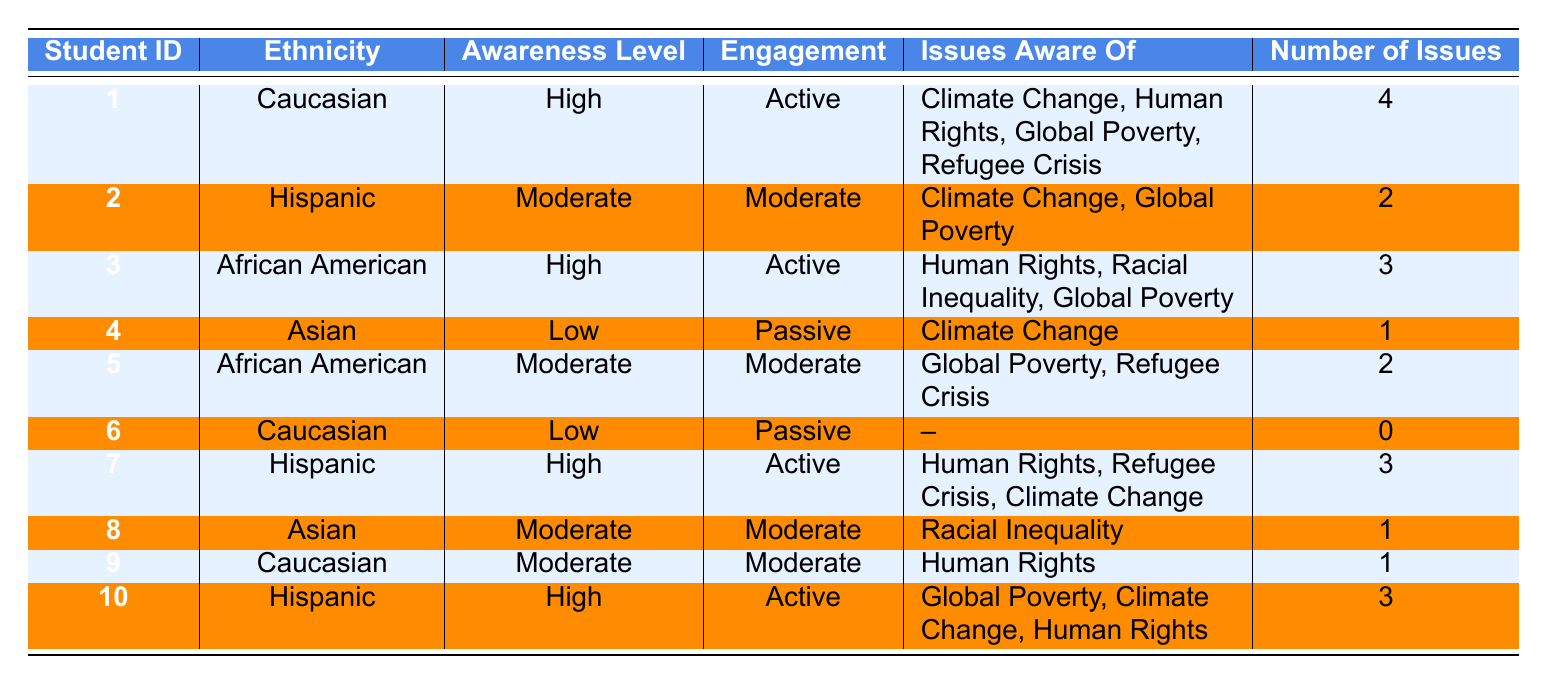What is the ethnic background of the student with the highest awareness level? The student with the highest awareness level is Student 1, who is Caucasian. There are two other students (Student 3 and Student 10) who also have a high awareness level, but since the question asks for the one with the highest level, Student 1 is the first listed.
Answer: Caucasian How many students have a low level of awareness? There are two students (Student 4 and Student 6) who have a low awareness level according to the table.
Answer: 2 Which ethnic group has the most students listed in the table? By counting the number of entries for each ethnicity, Caucasian has three students (1, 6, 9), Hispanic has three students (2, 7, 10), African American has two students (3, 5), and Asian has two students (4, 8). There is a tie between Caucasian and Hispanic for the most students, with three each.
Answer: Caucasian and Hispanic What percentage of Hispanic students have a high awareness level? There are three Hispanic students in total (2, 7, 10). Out of these, two (7 and 10) have a high awareness level. To calculate the percentage: (2 high awareness students / 3 total Hispanic students) * 100 = 66.67%.
Answer: 66.67% Is it true that all Asian students have a moderate awareness level? There are two Asian students (4 and 8). Student 4 has a low awareness level, while Student 8 has a moderate level. Therefore, it's not true that all Asian students have a moderate awareness level.
Answer: No What is the average number of issues aware of for students with high awareness? There are four students with high awareness levels (1, 3, 7, 10). The number of issues they are aware of are 4, 3, 3, and 3 respectively. To find the average: (4 + 3 + 3 + 3) / 4 = 3.25.
Answer: 3.25 How many issues is Student 9 aware of? Looking at Student 9’s row in the table, it states that they are aware of one issue, which is Human Rights.
Answer: 1 Which engagement level is most common among Caucasian students? Looking through the Caucasian students (1, 6, 9), we see that Student 1 and Student 9 both have an "Active" or "Moderate" engagement level, while Student 6 has a "Passive" level. Since two out of three students are either Active or Moderate, these levels are the most common.
Answer: Active and Moderate What are the issues that the most engaged Hispanic student is aware of? The most engaged Hispanic student is Student 10, with an "Active" engagement level. According to the table, they are aware of Global Poverty, Climate Change, and Human Rights.
Answer: Global Poverty, Climate Change, Human Rights 